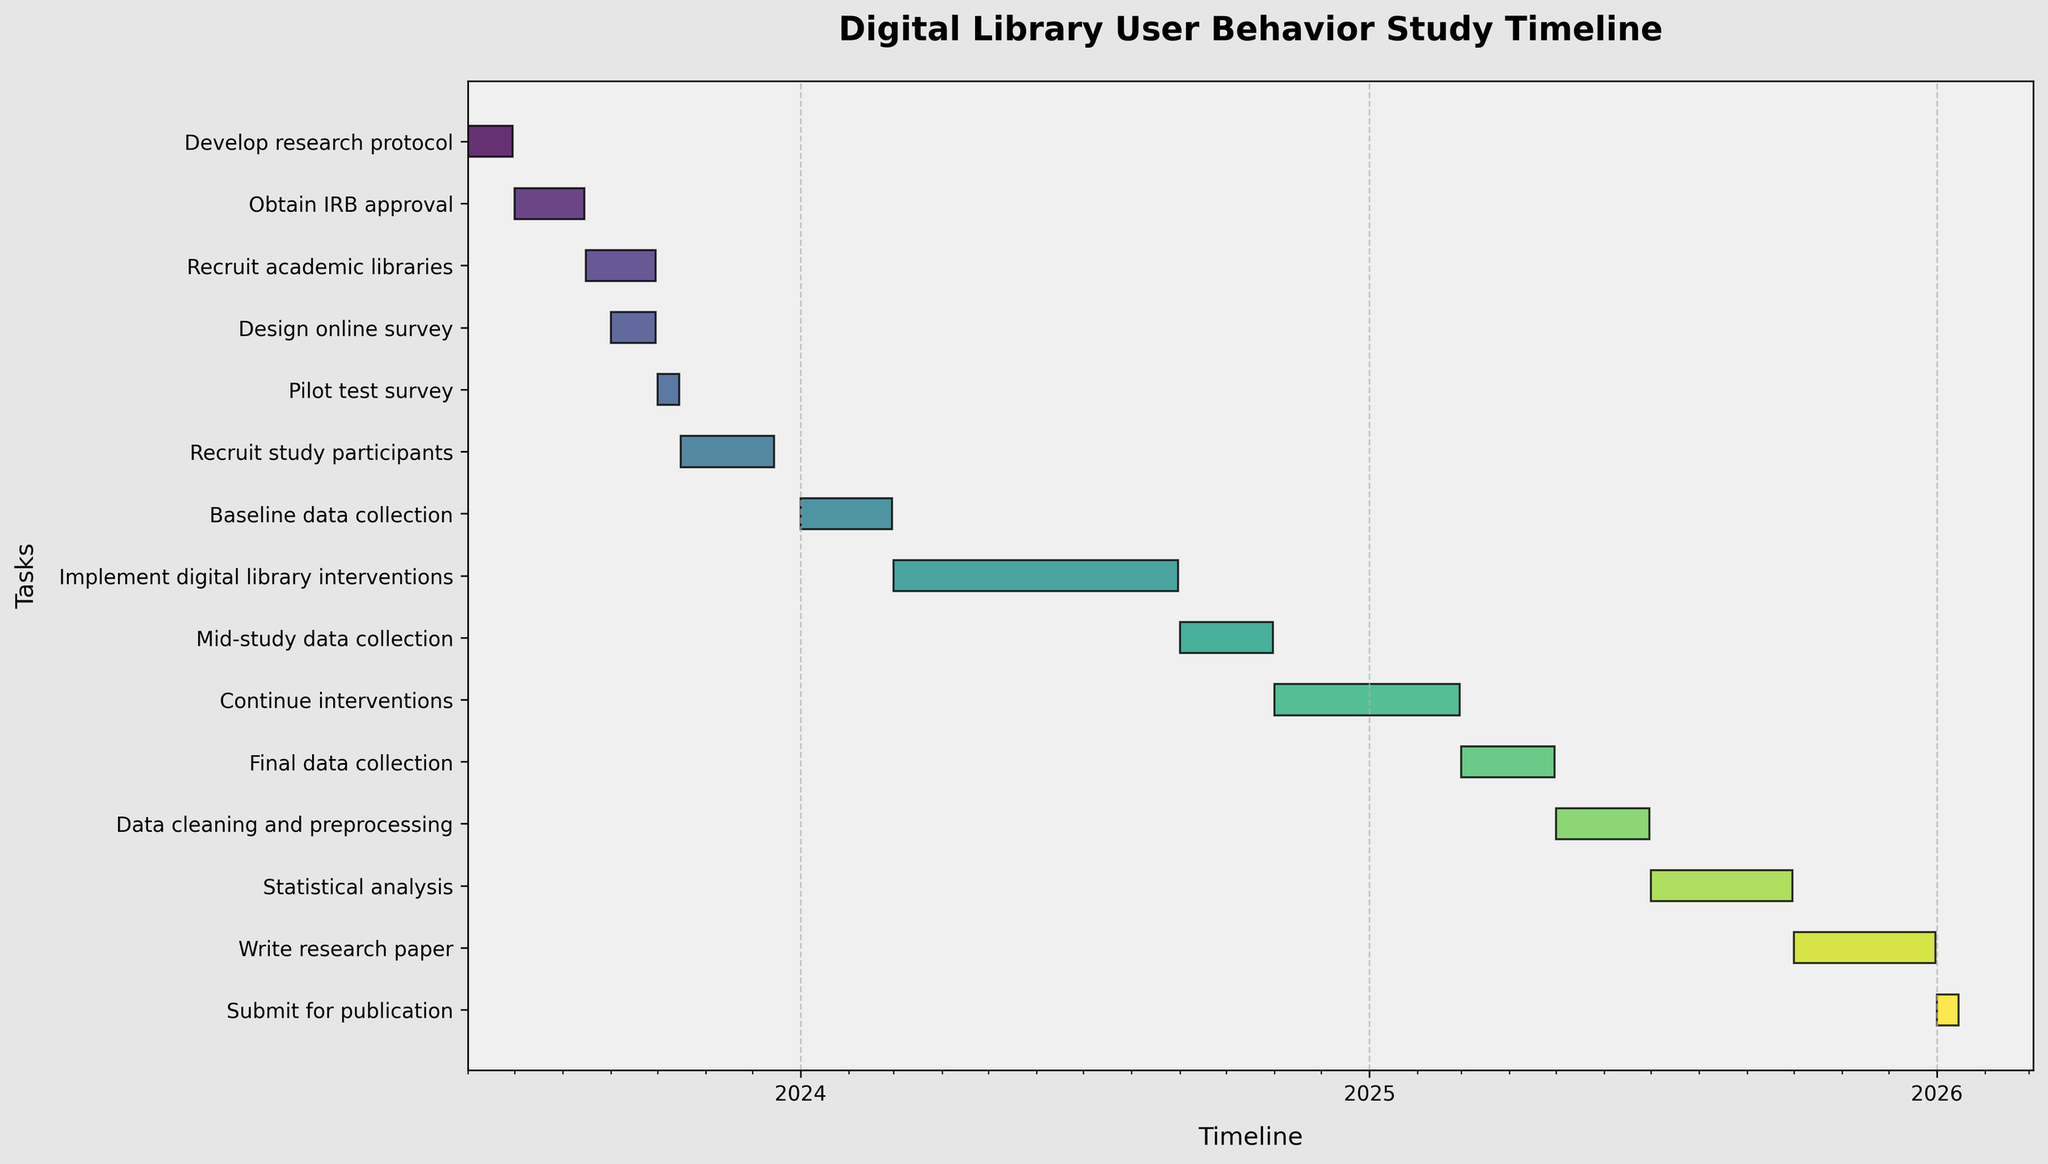What is the total duration of the 'Implement digital library interventions' task? To find the total duration, look at the start and end dates for the 'Implement digital library interventions' task. Subtract the start date (2024-03-01) from the end date (2024-08-31). The duration is 6 months.
Answer: 6 months Which task has the shortest duration, and what is that duration? To determine the shortest task, compare the durations of all tasks. The 'Pilot test survey' task runs from 2023-10-01 to 2023-10-15, lasting only 15 days.
Answer: 'Pilot test survey', 15 days What task starts immediately after 'Obtain IRB approval'? Identify the end date of 'Obtain IRB approval' (2023-08-15) and check which task begins right after. The task 'Recruit academic libraries' starts on 2023-08-16.
Answer: 'Recruit academic libraries' How long is the gap between the completion of 'Recruit study participants' and the start of 'Baseline data collection'? Find the end date of 'Recruit study participants' (2023-12-15) and the start date of 'Baseline data collection' (2024-01-01). Calculate the gap by subtracting the end date of the former from the start date of the latter, resulting in a gap of 17 days.
Answer: 17 days Which task overlaps in time with 'Recruit study participants' and what is the overlap period? 'Design online survey' end date (2023-09-30) should be examined to see any task that starts before its end. 'Pilot test survey' (starting 2023-10-01 and ending 2023-10-15) overlaps with 'Recruit study participants' (2023-10-16 to 2023-12-15). The overlap period is 15 days.
Answer: 'Pilot test survey', 15 days What is the duration of the 'Write research paper' phase, and how does it compare to the 'Data cleaning and preprocessing' phase? For the 'Write research paper' phase, calculate the duration from 2025-10-01 to 2025-12-31, which is 3 months. The 'Data cleaning and preprocessing' phase lasts from 2025-05-01 to 2025-06-30, equating to 2 months. Comparing both, the 'Write research paper' phase is 1 month longer.
Answer: 'Write research paper' is 1 month longer than 'Data cleaning and preprocessing' How many tasks start in the year 2024? Count the tasks by their start dates. The tasks that begin in 2024 are 'Baseline data collection' (2024-01-01), 'Implement digital library interventions' (2024-03-01), 'Mid-study data collection' (2024-09-01), and 'Continue interventions' (2024-11-01). Therefore, there are 4 tasks starting in 2024.
Answer: 4 tasks What's the duration of the overall study from the first task to the last task? The first task starts on 2023-06-01 and the last task ends on 2026-01-15. Calculate the duration by subtracting the start date of the first task from the end date of the last task, which totals approximately 2 years and 7.5 months.
Answer: Approximately 2 years and 7.5 months 